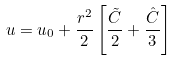<formula> <loc_0><loc_0><loc_500><loc_500>u = u _ { 0 } + \frac { r ^ { 2 } } { 2 } \left [ \frac { \tilde { C } } { 2 } + \frac { \hat { C } } { 3 } \right ]</formula> 